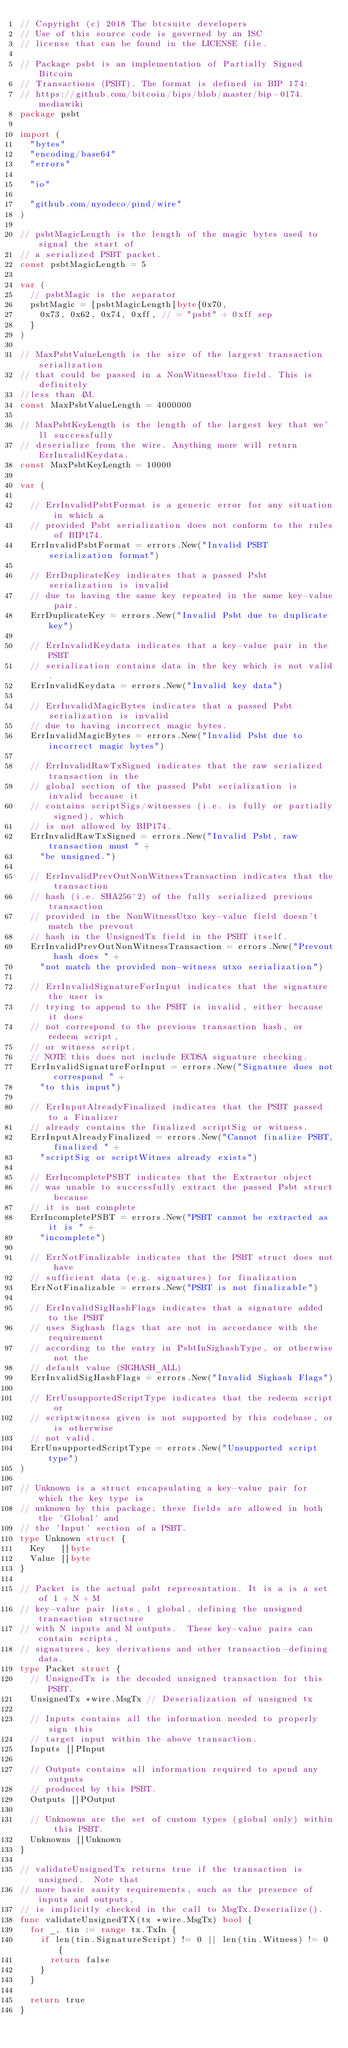<code> <loc_0><loc_0><loc_500><loc_500><_Go_>// Copyright (c) 2018 The btcsuite developers
// Use of this source code is governed by an ISC
// license that can be found in the LICENSE file.

// Package psbt is an implementation of Partially Signed Bitcoin
// Transactions (PSBT). The format is defined in BIP 174:
// https://github.com/bitcoin/bips/blob/master/bip-0174.mediawiki
package psbt

import (
	"bytes"
	"encoding/base64"
	"errors"

	"io"

	"github.com/nyodeco/pind/wire"
)

// psbtMagicLength is the length of the magic bytes used to signal the start of
// a serialized PSBT packet.
const psbtMagicLength = 5

var (
	// psbtMagic is the separator
	psbtMagic = [psbtMagicLength]byte{0x70,
		0x73, 0x62, 0x74, 0xff, // = "psbt" + 0xff sep
	}
)

// MaxPsbtValueLength is the size of the largest transaction serialization
// that could be passed in a NonWitnessUtxo field. This is definitely
//less than 4M.
const MaxPsbtValueLength = 4000000

// MaxPsbtKeyLength is the length of the largest key that we'll successfully
// deserialize from the wire. Anything more will return ErrInvalidKeydata.
const MaxPsbtKeyLength = 10000

var (

	// ErrInvalidPsbtFormat is a generic error for any situation in which a
	// provided Psbt serialization does not conform to the rules of BIP174.
	ErrInvalidPsbtFormat = errors.New("Invalid PSBT serialization format")

	// ErrDuplicateKey indicates that a passed Psbt serialization is invalid
	// due to having the same key repeated in the same key-value pair.
	ErrDuplicateKey = errors.New("Invalid Psbt due to duplicate key")

	// ErrInvalidKeydata indicates that a key-value pair in the PSBT
	// serialization contains data in the key which is not valid.
	ErrInvalidKeydata = errors.New("Invalid key data")

	// ErrInvalidMagicBytes indicates that a passed Psbt serialization is invalid
	// due to having incorrect magic bytes.
	ErrInvalidMagicBytes = errors.New("Invalid Psbt due to incorrect magic bytes")

	// ErrInvalidRawTxSigned indicates that the raw serialized transaction in the
	// global section of the passed Psbt serialization is invalid because it
	// contains scriptSigs/witnesses (i.e. is fully or partially signed), which
	// is not allowed by BIP174.
	ErrInvalidRawTxSigned = errors.New("Invalid Psbt, raw transaction must " +
		"be unsigned.")

	// ErrInvalidPrevOutNonWitnessTransaction indicates that the transaction
	// hash (i.e. SHA256^2) of the fully serialized previous transaction
	// provided in the NonWitnessUtxo key-value field doesn't match the prevout
	// hash in the UnsignedTx field in the PSBT itself.
	ErrInvalidPrevOutNonWitnessTransaction = errors.New("Prevout hash does " +
		"not match the provided non-witness utxo serialization")

	// ErrInvalidSignatureForInput indicates that the signature the user is
	// trying to append to the PSBT is invalid, either because it does
	// not correspond to the previous transaction hash, or redeem script,
	// or witness script.
	// NOTE this does not include ECDSA signature checking.
	ErrInvalidSignatureForInput = errors.New("Signature does not correspond " +
		"to this input")

	// ErrInputAlreadyFinalized indicates that the PSBT passed to a Finalizer
	// already contains the finalized scriptSig or witness.
	ErrInputAlreadyFinalized = errors.New("Cannot finalize PSBT, finalized " +
		"scriptSig or scriptWitnes already exists")

	// ErrIncompletePSBT indicates that the Extractor object
	// was unable to successfully extract the passed Psbt struct because
	// it is not complete
	ErrIncompletePSBT = errors.New("PSBT cannot be extracted as it is " +
		"incomplete")

	// ErrNotFinalizable indicates that the PSBT struct does not have
	// sufficient data (e.g. signatures) for finalization
	ErrNotFinalizable = errors.New("PSBT is not finalizable")

	// ErrInvalidSigHashFlags indicates that a signature added to the PSBT
	// uses Sighash flags that are not in accordance with the requirement
	// according to the entry in PsbtInSighashType, or otherwise not the
	// default value (SIGHASH_ALL)
	ErrInvalidSigHashFlags = errors.New("Invalid Sighash Flags")

	// ErrUnsupportedScriptType indicates that the redeem script or
	// scriptwitness given is not supported by this codebase, or is otherwise
	// not valid.
	ErrUnsupportedScriptType = errors.New("Unsupported script type")
)

// Unknown is a struct encapsulating a key-value pair for which the key type is
// unknown by this package; these fields are allowed in both the 'Global' and
// the 'Input' section of a PSBT.
type Unknown struct {
	Key   []byte
	Value []byte
}

// Packet is the actual psbt repreesntation. It is a is a set of 1 + N + M
// key-value pair lists, 1 global, defining the unsigned transaction structure
// with N inputs and M outputs.  These key-value pairs can contain scripts,
// signatures, key derivations and other transaction-defining data.
type Packet struct {
	// UnsignedTx is the decoded unsigned transaction for this PSBT.
	UnsignedTx *wire.MsgTx // Deserialization of unsigned tx

	// Inputs contains all the information needed to properly sign this
	// target input within the above transaction.
	Inputs []PInput

	// Outputs contains all information required to spend any outputs
	// produced by this PSBT.
	Outputs []POutput

	// Unknowns are the set of custom types (global only) within this PSBT.
	Unknowns []Unknown
}

// validateUnsignedTx returns true if the transaction is unsigned.  Note that
// more basic sanity requirements, such as the presence of inputs and outputs,
// is implicitly checked in the call to MsgTx.Deserialize().
func validateUnsignedTX(tx *wire.MsgTx) bool {
	for _, tin := range tx.TxIn {
		if len(tin.SignatureScript) != 0 || len(tin.Witness) != 0 {
			return false
		}
	}

	return true
}
</code> 